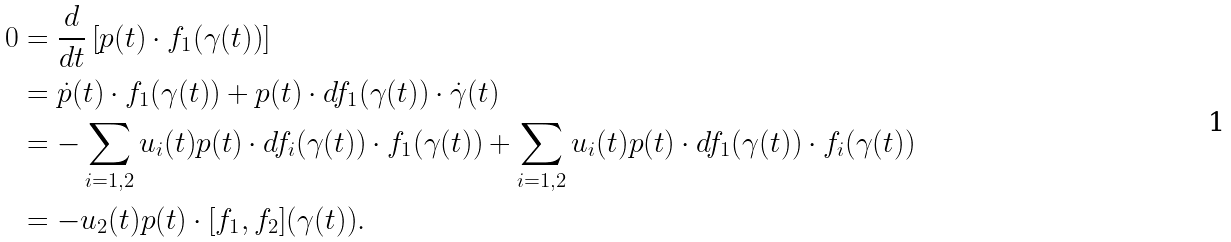Convert formula to latex. <formula><loc_0><loc_0><loc_500><loc_500>0 & = \frac { d } { d t } \left [ p ( t ) \cdot f _ { 1 } ( \gamma ( t ) ) \right ] \\ & = \dot { p } ( t ) \cdot f _ { 1 } ( \gamma ( t ) ) + p ( t ) \cdot d f _ { 1 } ( \gamma ( t ) ) \cdot \dot { \gamma } ( t ) \\ & = - \sum _ { i = 1 , 2 } u _ { i } ( t ) p ( t ) \cdot d f _ { i } ( \gamma ( t ) ) \cdot f _ { 1 } ( \gamma ( t ) ) + \sum _ { i = 1 , 2 } u _ { i } ( t ) p ( t ) \cdot d f _ { 1 } ( \gamma ( t ) ) \cdot f _ { i } ( \gamma ( t ) ) \\ & = - u _ { 2 } ( t ) p ( t ) \cdot [ f _ { 1 } , f _ { 2 } ] ( \gamma ( t ) ) .</formula> 